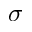<formula> <loc_0><loc_0><loc_500><loc_500>\sigma</formula> 